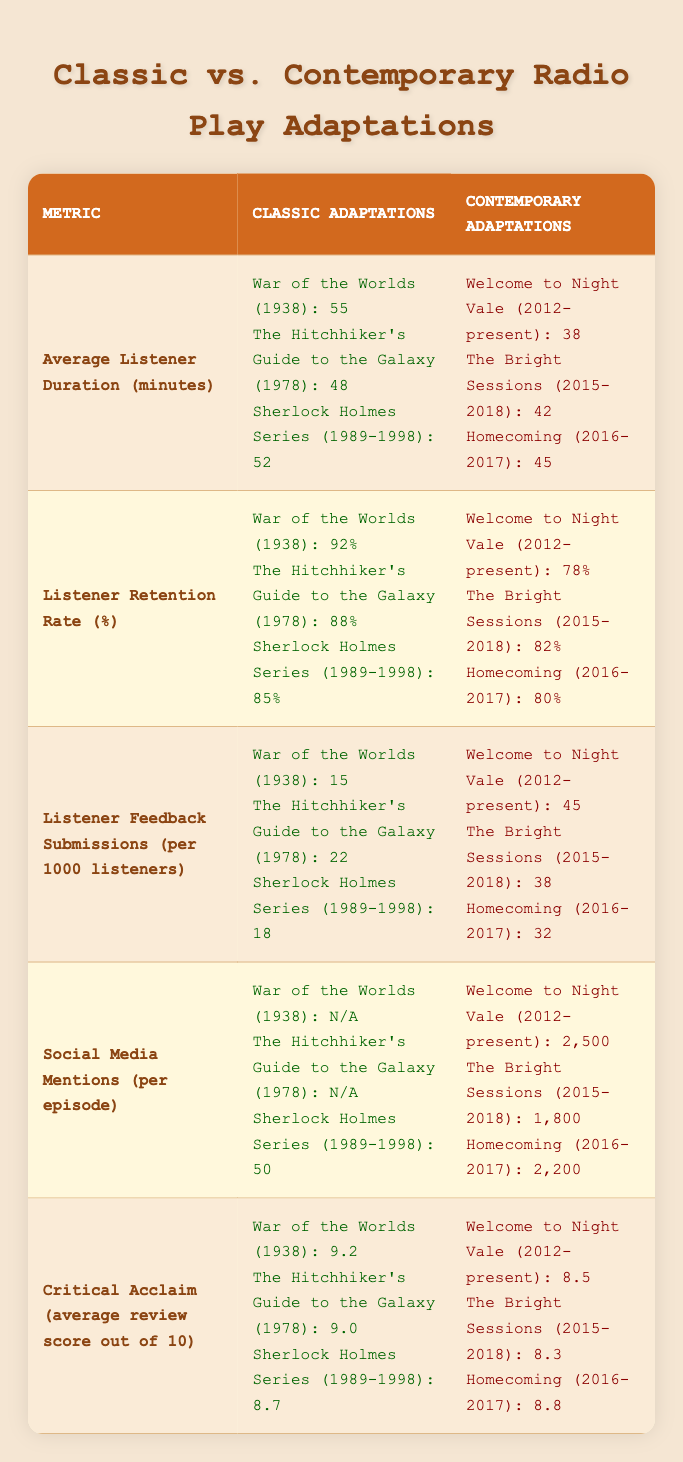What is the average listener duration for classic adaptations? The table lists the average listener duration for three classic adaptations: War of the Worlds (55), The Hitchhiker's Guide to the Galaxy (48), and Sherlock Holmes Series (52). To find the average, sum these values: 55 + 48 + 52 = 155. Then divide by the number of adaptations (3): 155 / 3 = 51.67. Thus, the average listener duration is approximately 51.67 minutes.
Answer: 51.67 minutes Which contemporary adaptation has the highest listener feedback submissions? Looking at the listener feedback submissions per 1000 listeners for contemporary adaptations, the figures are 45 for Welcome to Night Vale, 38 for The Bright Sessions, and 32 for Homecoming. The highest value is 45 from Welcome to Night Vale.
Answer: Welcome to Night Vale Is the listener retention rate higher for classic or contemporary adaptations? The listener retention rates for the classic adaptations are 92%, 88%, and 85%. For contemporary adaptations, they are 78%, 82%, and 80%. The lowest of classic adaptations (85%) is higher than the highest of contemporary adaptations (82%), indicating that classic adaptations have a higher retention rate overall.
Answer: Yes What is the difference in average review scores between classic and contemporary adaptations? The average review scores for classic adaptations are 9.2, 9.0, and 8.7, yielding an average of (9.2 + 9.0 + 8.7) / 3 = 8.97. For contemporary adaptations, the scores are 8.5, 8.3, and 8.8, which average (8.5 + 8.3 + 8.8) / 3 = 8.53. The difference between these averages is 8.97 - 8.53 = 0.44.
Answer: 0.44 Are there any classic adaptations with a social media mentions metric? The table shows social media mentions for the classic adaptations: War of the Worlds has N/A, The Hitchhiker's Guide to the Galaxy has N/A, and Sherlock Holmes Series has 50. Since there is one adaptation with a numerical value (Sherlock Holmes Series), the answer is yes.
Answer: Yes Which adaptation has the most significant listener engagement based on listener feedback submissions and social media mentions? For listener feedback submissions, contemporary adaptations have higher values: 45 for Welcome to Night Vale, 38 for The Bright Sessions, and 32 for Homecoming. The only classic adaptation with a value is Sherlock Holmes Series, which has 18. For social media mentions, contemporary adaptations: Welcome to Night Vale has 2500, The Bright Sessions has 1800, and Homecoming has 2200, while classic adaptations have N/A or 50 for Sherlock Holmes Series. The highest overall feedback submission was from Welcome to Night Vale (45) and for social media mentions from Welcome to Night Vale (2500). Considering both categories collectively indicates that Welcome to Night Vale shows the most significant engagement.
Answer: Welcome to Night Vale 